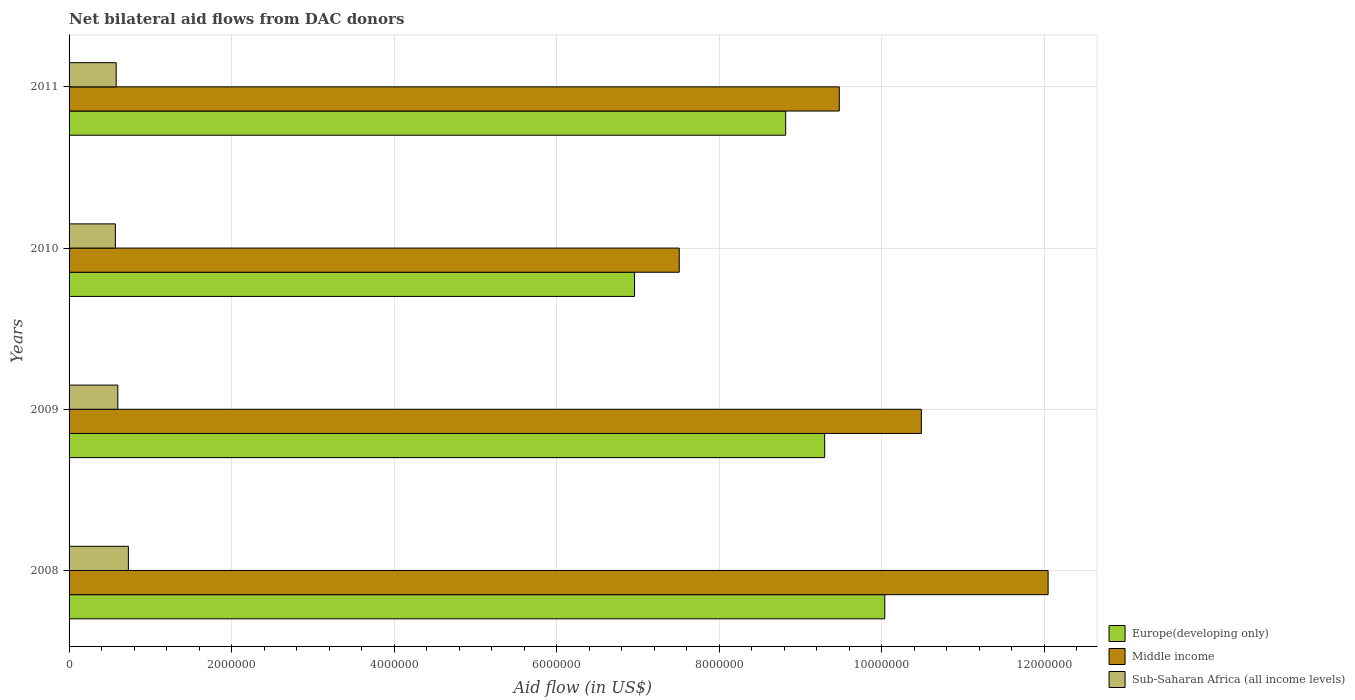How many different coloured bars are there?
Keep it short and to the point. 3. Are the number of bars per tick equal to the number of legend labels?
Give a very brief answer. Yes. Are the number of bars on each tick of the Y-axis equal?
Your answer should be very brief. Yes. How many bars are there on the 2nd tick from the top?
Provide a succinct answer. 3. What is the label of the 3rd group of bars from the top?
Give a very brief answer. 2009. What is the net bilateral aid flow in Sub-Saharan Africa (all income levels) in 2008?
Offer a terse response. 7.30e+05. Across all years, what is the maximum net bilateral aid flow in Sub-Saharan Africa (all income levels)?
Your answer should be very brief. 7.30e+05. Across all years, what is the minimum net bilateral aid flow in Middle income?
Make the answer very short. 7.51e+06. In which year was the net bilateral aid flow in Europe(developing only) maximum?
Your response must be concise. 2008. In which year was the net bilateral aid flow in Middle income minimum?
Keep it short and to the point. 2010. What is the total net bilateral aid flow in Middle income in the graph?
Your response must be concise. 3.95e+07. What is the difference between the net bilateral aid flow in Sub-Saharan Africa (all income levels) in 2008 and that in 2011?
Offer a terse response. 1.50e+05. What is the difference between the net bilateral aid flow in Sub-Saharan Africa (all income levels) in 2009 and the net bilateral aid flow in Europe(developing only) in 2008?
Ensure brevity in your answer.  -9.44e+06. What is the average net bilateral aid flow in Sub-Saharan Africa (all income levels) per year?
Keep it short and to the point. 6.20e+05. In the year 2011, what is the difference between the net bilateral aid flow in Middle income and net bilateral aid flow in Europe(developing only)?
Your answer should be compact. 6.60e+05. What is the ratio of the net bilateral aid flow in Middle income in 2008 to that in 2010?
Ensure brevity in your answer.  1.6. Is the difference between the net bilateral aid flow in Middle income in 2008 and 2010 greater than the difference between the net bilateral aid flow in Europe(developing only) in 2008 and 2010?
Give a very brief answer. Yes. What is the difference between the highest and the lowest net bilateral aid flow in Sub-Saharan Africa (all income levels)?
Your answer should be very brief. 1.60e+05. In how many years, is the net bilateral aid flow in Middle income greater than the average net bilateral aid flow in Middle income taken over all years?
Make the answer very short. 2. What does the 2nd bar from the top in 2011 represents?
Your response must be concise. Middle income. What does the 1st bar from the bottom in 2008 represents?
Keep it short and to the point. Europe(developing only). Is it the case that in every year, the sum of the net bilateral aid flow in Sub-Saharan Africa (all income levels) and net bilateral aid flow in Europe(developing only) is greater than the net bilateral aid flow in Middle income?
Ensure brevity in your answer.  No. Are all the bars in the graph horizontal?
Keep it short and to the point. Yes. What is the difference between two consecutive major ticks on the X-axis?
Make the answer very short. 2.00e+06. Are the values on the major ticks of X-axis written in scientific E-notation?
Provide a short and direct response. No. What is the title of the graph?
Provide a succinct answer. Net bilateral aid flows from DAC donors. Does "East Asia (all income levels)" appear as one of the legend labels in the graph?
Provide a succinct answer. No. What is the label or title of the X-axis?
Offer a very short reply. Aid flow (in US$). What is the label or title of the Y-axis?
Make the answer very short. Years. What is the Aid flow (in US$) in Europe(developing only) in 2008?
Keep it short and to the point. 1.00e+07. What is the Aid flow (in US$) of Middle income in 2008?
Give a very brief answer. 1.20e+07. What is the Aid flow (in US$) in Sub-Saharan Africa (all income levels) in 2008?
Keep it short and to the point. 7.30e+05. What is the Aid flow (in US$) of Europe(developing only) in 2009?
Offer a terse response. 9.30e+06. What is the Aid flow (in US$) in Middle income in 2009?
Offer a terse response. 1.05e+07. What is the Aid flow (in US$) in Europe(developing only) in 2010?
Your response must be concise. 6.96e+06. What is the Aid flow (in US$) in Middle income in 2010?
Keep it short and to the point. 7.51e+06. What is the Aid flow (in US$) of Sub-Saharan Africa (all income levels) in 2010?
Provide a short and direct response. 5.70e+05. What is the Aid flow (in US$) of Europe(developing only) in 2011?
Your response must be concise. 8.82e+06. What is the Aid flow (in US$) of Middle income in 2011?
Provide a short and direct response. 9.48e+06. What is the Aid flow (in US$) of Sub-Saharan Africa (all income levels) in 2011?
Your response must be concise. 5.80e+05. Across all years, what is the maximum Aid flow (in US$) in Europe(developing only)?
Ensure brevity in your answer.  1.00e+07. Across all years, what is the maximum Aid flow (in US$) of Middle income?
Offer a terse response. 1.20e+07. Across all years, what is the maximum Aid flow (in US$) in Sub-Saharan Africa (all income levels)?
Provide a succinct answer. 7.30e+05. Across all years, what is the minimum Aid flow (in US$) in Europe(developing only)?
Keep it short and to the point. 6.96e+06. Across all years, what is the minimum Aid flow (in US$) of Middle income?
Ensure brevity in your answer.  7.51e+06. Across all years, what is the minimum Aid flow (in US$) in Sub-Saharan Africa (all income levels)?
Offer a terse response. 5.70e+05. What is the total Aid flow (in US$) of Europe(developing only) in the graph?
Offer a very short reply. 3.51e+07. What is the total Aid flow (in US$) in Middle income in the graph?
Make the answer very short. 3.95e+07. What is the total Aid flow (in US$) in Sub-Saharan Africa (all income levels) in the graph?
Offer a terse response. 2.48e+06. What is the difference between the Aid flow (in US$) in Europe(developing only) in 2008 and that in 2009?
Your response must be concise. 7.40e+05. What is the difference between the Aid flow (in US$) of Middle income in 2008 and that in 2009?
Your response must be concise. 1.56e+06. What is the difference between the Aid flow (in US$) of Europe(developing only) in 2008 and that in 2010?
Ensure brevity in your answer.  3.08e+06. What is the difference between the Aid flow (in US$) in Middle income in 2008 and that in 2010?
Make the answer very short. 4.54e+06. What is the difference between the Aid flow (in US$) in Sub-Saharan Africa (all income levels) in 2008 and that in 2010?
Provide a succinct answer. 1.60e+05. What is the difference between the Aid flow (in US$) in Europe(developing only) in 2008 and that in 2011?
Offer a terse response. 1.22e+06. What is the difference between the Aid flow (in US$) of Middle income in 2008 and that in 2011?
Offer a terse response. 2.57e+06. What is the difference between the Aid flow (in US$) in Sub-Saharan Africa (all income levels) in 2008 and that in 2011?
Provide a short and direct response. 1.50e+05. What is the difference between the Aid flow (in US$) of Europe(developing only) in 2009 and that in 2010?
Provide a succinct answer. 2.34e+06. What is the difference between the Aid flow (in US$) in Middle income in 2009 and that in 2010?
Provide a short and direct response. 2.98e+06. What is the difference between the Aid flow (in US$) of Europe(developing only) in 2009 and that in 2011?
Your answer should be compact. 4.80e+05. What is the difference between the Aid flow (in US$) in Middle income in 2009 and that in 2011?
Provide a succinct answer. 1.01e+06. What is the difference between the Aid flow (in US$) of Europe(developing only) in 2010 and that in 2011?
Give a very brief answer. -1.86e+06. What is the difference between the Aid flow (in US$) of Middle income in 2010 and that in 2011?
Provide a short and direct response. -1.97e+06. What is the difference between the Aid flow (in US$) of Sub-Saharan Africa (all income levels) in 2010 and that in 2011?
Your answer should be very brief. -10000. What is the difference between the Aid flow (in US$) in Europe(developing only) in 2008 and the Aid flow (in US$) in Middle income in 2009?
Give a very brief answer. -4.50e+05. What is the difference between the Aid flow (in US$) in Europe(developing only) in 2008 and the Aid flow (in US$) in Sub-Saharan Africa (all income levels) in 2009?
Offer a terse response. 9.44e+06. What is the difference between the Aid flow (in US$) in Middle income in 2008 and the Aid flow (in US$) in Sub-Saharan Africa (all income levels) in 2009?
Ensure brevity in your answer.  1.14e+07. What is the difference between the Aid flow (in US$) of Europe(developing only) in 2008 and the Aid flow (in US$) of Middle income in 2010?
Your response must be concise. 2.53e+06. What is the difference between the Aid flow (in US$) in Europe(developing only) in 2008 and the Aid flow (in US$) in Sub-Saharan Africa (all income levels) in 2010?
Provide a short and direct response. 9.47e+06. What is the difference between the Aid flow (in US$) of Middle income in 2008 and the Aid flow (in US$) of Sub-Saharan Africa (all income levels) in 2010?
Your answer should be compact. 1.15e+07. What is the difference between the Aid flow (in US$) in Europe(developing only) in 2008 and the Aid flow (in US$) in Middle income in 2011?
Provide a succinct answer. 5.60e+05. What is the difference between the Aid flow (in US$) of Europe(developing only) in 2008 and the Aid flow (in US$) of Sub-Saharan Africa (all income levels) in 2011?
Provide a short and direct response. 9.46e+06. What is the difference between the Aid flow (in US$) of Middle income in 2008 and the Aid flow (in US$) of Sub-Saharan Africa (all income levels) in 2011?
Provide a short and direct response. 1.15e+07. What is the difference between the Aid flow (in US$) of Europe(developing only) in 2009 and the Aid flow (in US$) of Middle income in 2010?
Keep it short and to the point. 1.79e+06. What is the difference between the Aid flow (in US$) in Europe(developing only) in 2009 and the Aid flow (in US$) in Sub-Saharan Africa (all income levels) in 2010?
Make the answer very short. 8.73e+06. What is the difference between the Aid flow (in US$) in Middle income in 2009 and the Aid flow (in US$) in Sub-Saharan Africa (all income levels) in 2010?
Offer a very short reply. 9.92e+06. What is the difference between the Aid flow (in US$) in Europe(developing only) in 2009 and the Aid flow (in US$) in Middle income in 2011?
Your response must be concise. -1.80e+05. What is the difference between the Aid flow (in US$) of Europe(developing only) in 2009 and the Aid flow (in US$) of Sub-Saharan Africa (all income levels) in 2011?
Provide a succinct answer. 8.72e+06. What is the difference between the Aid flow (in US$) of Middle income in 2009 and the Aid flow (in US$) of Sub-Saharan Africa (all income levels) in 2011?
Provide a succinct answer. 9.91e+06. What is the difference between the Aid flow (in US$) of Europe(developing only) in 2010 and the Aid flow (in US$) of Middle income in 2011?
Provide a succinct answer. -2.52e+06. What is the difference between the Aid flow (in US$) of Europe(developing only) in 2010 and the Aid flow (in US$) of Sub-Saharan Africa (all income levels) in 2011?
Provide a succinct answer. 6.38e+06. What is the difference between the Aid flow (in US$) of Middle income in 2010 and the Aid flow (in US$) of Sub-Saharan Africa (all income levels) in 2011?
Offer a terse response. 6.93e+06. What is the average Aid flow (in US$) of Europe(developing only) per year?
Your answer should be very brief. 8.78e+06. What is the average Aid flow (in US$) of Middle income per year?
Provide a succinct answer. 9.88e+06. What is the average Aid flow (in US$) in Sub-Saharan Africa (all income levels) per year?
Provide a short and direct response. 6.20e+05. In the year 2008, what is the difference between the Aid flow (in US$) of Europe(developing only) and Aid flow (in US$) of Middle income?
Provide a succinct answer. -2.01e+06. In the year 2008, what is the difference between the Aid flow (in US$) in Europe(developing only) and Aid flow (in US$) in Sub-Saharan Africa (all income levels)?
Provide a short and direct response. 9.31e+06. In the year 2008, what is the difference between the Aid flow (in US$) of Middle income and Aid flow (in US$) of Sub-Saharan Africa (all income levels)?
Make the answer very short. 1.13e+07. In the year 2009, what is the difference between the Aid flow (in US$) of Europe(developing only) and Aid flow (in US$) of Middle income?
Ensure brevity in your answer.  -1.19e+06. In the year 2009, what is the difference between the Aid flow (in US$) in Europe(developing only) and Aid flow (in US$) in Sub-Saharan Africa (all income levels)?
Ensure brevity in your answer.  8.70e+06. In the year 2009, what is the difference between the Aid flow (in US$) in Middle income and Aid flow (in US$) in Sub-Saharan Africa (all income levels)?
Provide a short and direct response. 9.89e+06. In the year 2010, what is the difference between the Aid flow (in US$) in Europe(developing only) and Aid flow (in US$) in Middle income?
Offer a terse response. -5.50e+05. In the year 2010, what is the difference between the Aid flow (in US$) of Europe(developing only) and Aid flow (in US$) of Sub-Saharan Africa (all income levels)?
Your answer should be compact. 6.39e+06. In the year 2010, what is the difference between the Aid flow (in US$) of Middle income and Aid flow (in US$) of Sub-Saharan Africa (all income levels)?
Provide a short and direct response. 6.94e+06. In the year 2011, what is the difference between the Aid flow (in US$) in Europe(developing only) and Aid flow (in US$) in Middle income?
Give a very brief answer. -6.60e+05. In the year 2011, what is the difference between the Aid flow (in US$) of Europe(developing only) and Aid flow (in US$) of Sub-Saharan Africa (all income levels)?
Your answer should be very brief. 8.24e+06. In the year 2011, what is the difference between the Aid flow (in US$) of Middle income and Aid flow (in US$) of Sub-Saharan Africa (all income levels)?
Provide a short and direct response. 8.90e+06. What is the ratio of the Aid flow (in US$) in Europe(developing only) in 2008 to that in 2009?
Your answer should be compact. 1.08. What is the ratio of the Aid flow (in US$) of Middle income in 2008 to that in 2009?
Your answer should be very brief. 1.15. What is the ratio of the Aid flow (in US$) of Sub-Saharan Africa (all income levels) in 2008 to that in 2009?
Provide a succinct answer. 1.22. What is the ratio of the Aid flow (in US$) of Europe(developing only) in 2008 to that in 2010?
Give a very brief answer. 1.44. What is the ratio of the Aid flow (in US$) in Middle income in 2008 to that in 2010?
Provide a succinct answer. 1.6. What is the ratio of the Aid flow (in US$) in Sub-Saharan Africa (all income levels) in 2008 to that in 2010?
Make the answer very short. 1.28. What is the ratio of the Aid flow (in US$) in Europe(developing only) in 2008 to that in 2011?
Your response must be concise. 1.14. What is the ratio of the Aid flow (in US$) of Middle income in 2008 to that in 2011?
Provide a succinct answer. 1.27. What is the ratio of the Aid flow (in US$) of Sub-Saharan Africa (all income levels) in 2008 to that in 2011?
Your response must be concise. 1.26. What is the ratio of the Aid flow (in US$) of Europe(developing only) in 2009 to that in 2010?
Make the answer very short. 1.34. What is the ratio of the Aid flow (in US$) of Middle income in 2009 to that in 2010?
Give a very brief answer. 1.4. What is the ratio of the Aid flow (in US$) in Sub-Saharan Africa (all income levels) in 2009 to that in 2010?
Your answer should be compact. 1.05. What is the ratio of the Aid flow (in US$) of Europe(developing only) in 2009 to that in 2011?
Provide a short and direct response. 1.05. What is the ratio of the Aid flow (in US$) of Middle income in 2009 to that in 2011?
Your answer should be very brief. 1.11. What is the ratio of the Aid flow (in US$) in Sub-Saharan Africa (all income levels) in 2009 to that in 2011?
Your answer should be very brief. 1.03. What is the ratio of the Aid flow (in US$) of Europe(developing only) in 2010 to that in 2011?
Offer a terse response. 0.79. What is the ratio of the Aid flow (in US$) of Middle income in 2010 to that in 2011?
Ensure brevity in your answer.  0.79. What is the ratio of the Aid flow (in US$) in Sub-Saharan Africa (all income levels) in 2010 to that in 2011?
Your response must be concise. 0.98. What is the difference between the highest and the second highest Aid flow (in US$) in Europe(developing only)?
Your response must be concise. 7.40e+05. What is the difference between the highest and the second highest Aid flow (in US$) in Middle income?
Give a very brief answer. 1.56e+06. What is the difference between the highest and the second highest Aid flow (in US$) in Sub-Saharan Africa (all income levels)?
Ensure brevity in your answer.  1.30e+05. What is the difference between the highest and the lowest Aid flow (in US$) in Europe(developing only)?
Offer a terse response. 3.08e+06. What is the difference between the highest and the lowest Aid flow (in US$) of Middle income?
Offer a very short reply. 4.54e+06. What is the difference between the highest and the lowest Aid flow (in US$) in Sub-Saharan Africa (all income levels)?
Provide a short and direct response. 1.60e+05. 